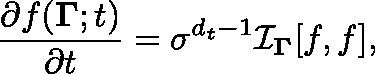Convert formula to latex. <formula><loc_0><loc_0><loc_500><loc_500>\frac { \partial f ( { \Gamma } ; t ) } { \partial t } = \sigma ^ { { d _ { t } } - 1 } \mathcal { I } _ { \Gamma } [ f , f ] ,</formula> 